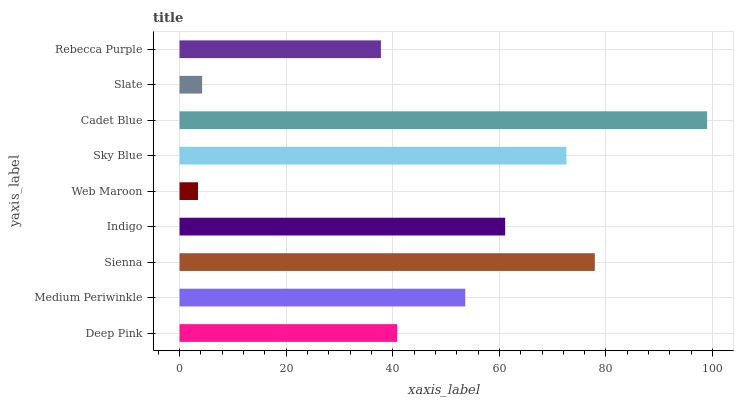Is Web Maroon the minimum?
Answer yes or no. Yes. Is Cadet Blue the maximum?
Answer yes or no. Yes. Is Medium Periwinkle the minimum?
Answer yes or no. No. Is Medium Periwinkle the maximum?
Answer yes or no. No. Is Medium Periwinkle greater than Deep Pink?
Answer yes or no. Yes. Is Deep Pink less than Medium Periwinkle?
Answer yes or no. Yes. Is Deep Pink greater than Medium Periwinkle?
Answer yes or no. No. Is Medium Periwinkle less than Deep Pink?
Answer yes or no. No. Is Medium Periwinkle the high median?
Answer yes or no. Yes. Is Medium Periwinkle the low median?
Answer yes or no. Yes. Is Rebecca Purple the high median?
Answer yes or no. No. Is Indigo the low median?
Answer yes or no. No. 